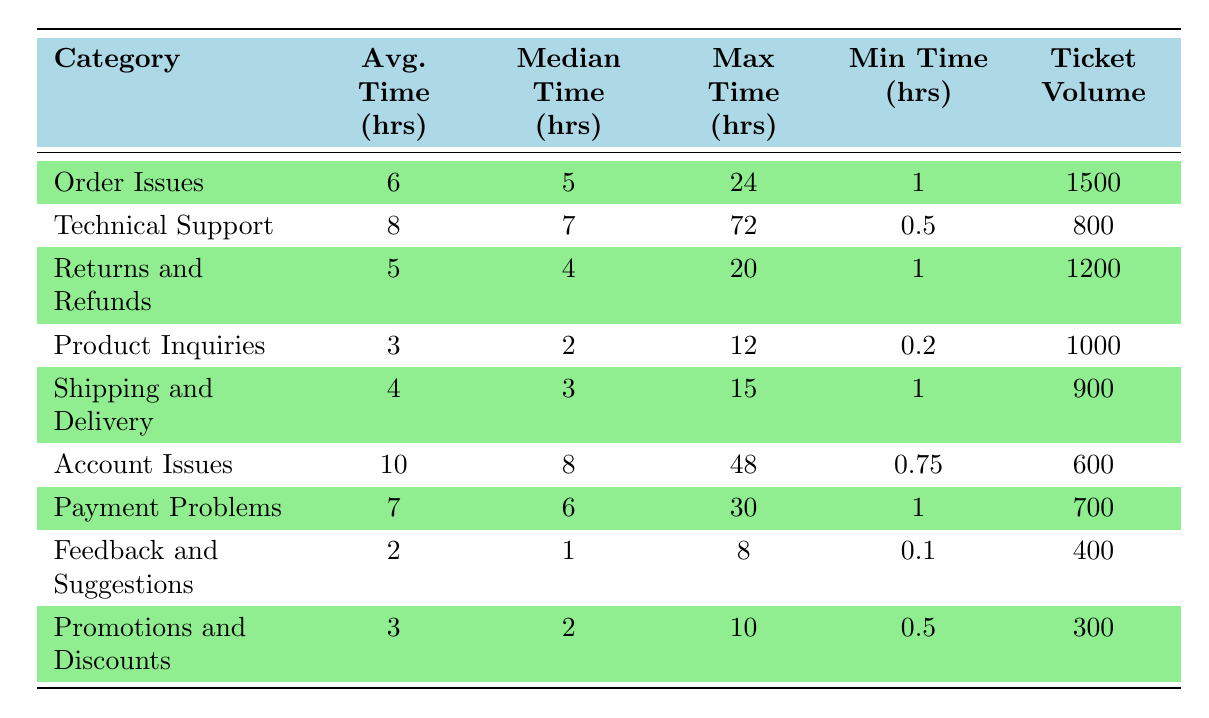What is the category with the shortest average resolution time? The average resolution times of the categories are listed in the table. "Feedback and Suggestions" has the shortest average resolution time of 2 hours.
Answer: Feedback and Suggestions Which category has the highest ticket volume? Looking at the "Ticket Volume" column, "Order Issues" has the highest volume at 1500 tickets.
Answer: Order Issues What is the median resolution time for Technical Support tickets? The table specifies that the median resolution time for "Technical Support" is 7 hours.
Answer: 7 hours Is the maximum resolution time for Returns and Refunds greater than for Product Inquiries? The maximum resolution time for "Returns and Refunds" is 20 hours, while for "Product Inquiries" it is 12 hours. Since 20 is greater than 12, this statement is true.
Answer: Yes Calculate the difference in average resolution time between Account Issues and Shipping and Delivery. The average for "Account Issues" is 10 hours, and for "Shipping and Delivery" it is 4 hours. The difference is 10 - 4 = 6 hours.
Answer: 6 hours What is the average resolution time for all categories combined? To find the overall average, sum all average times (6 + 8 + 5 + 3 + 4 + 10 + 7 + 2 + 3 = 48) and divide by the number of categories (9). 48 / 9 = 5.33 hours.
Answer: 5.33 hours Which category has the longest maximum resolution time? The "Technical Support" category has the longest maximum resolution time, which is 72 hours, compared to the others.
Answer: Technical Support Is the minimum resolution time for Payment Problems higher than the minimum for Returns and Refunds? The minimum for "Payment Problems" is 1 hour, while for "Returns and Refunds," it is also 1 hour. Since they are equal, the statement is false.
Answer: No What is the average resolution time for categories with a ticket volume greater than 1000? The categories with volumes greater than 1000 are "Order Issues," "Returns and Refunds," and "Product Inquiries." Their average times are 6, 5, and 3 hours respectively. The average is (6 + 5 + 3) / 3 = 14 / 3 = 4.67 hours.
Answer: 4.67 hours What percentage of the total tickets comes from the category with the highest ticket volume? The total ticket volume is 1500 + 800 + 1200 + 1000 + 900 + 600 + 700 + 400 + 300 = 6100. The highest volume is "Order Issues" with 1500 tickets. (1500 / 6100) * 100 = 24.59%.
Answer: 24.59% 